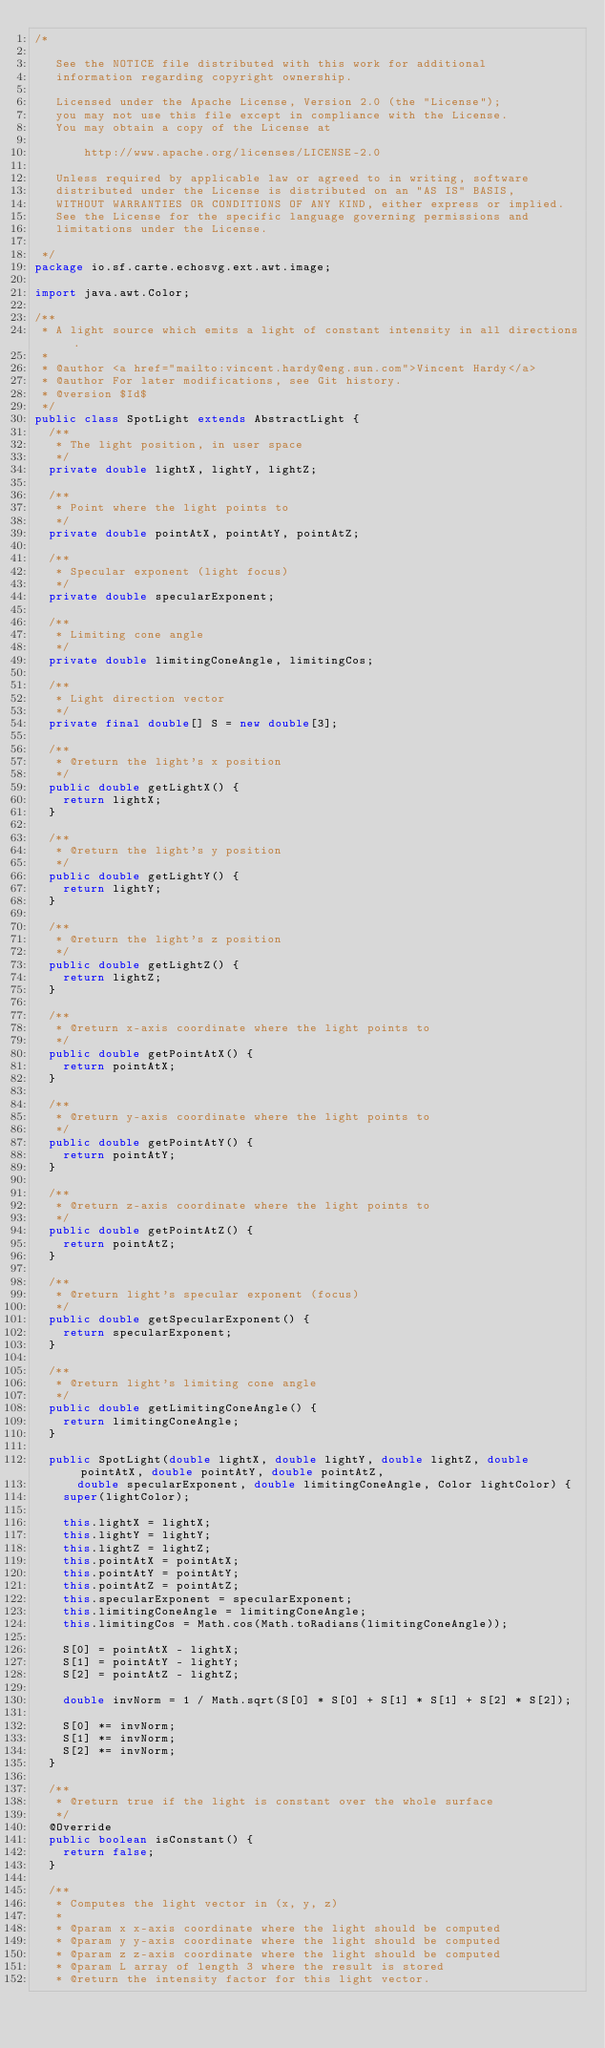Convert code to text. <code><loc_0><loc_0><loc_500><loc_500><_Java_>/*

   See the NOTICE file distributed with this work for additional
   information regarding copyright ownership.

   Licensed under the Apache License, Version 2.0 (the "License");
   you may not use this file except in compliance with the License.
   You may obtain a copy of the License at

       http://www.apache.org/licenses/LICENSE-2.0

   Unless required by applicable law or agreed to in writing, software
   distributed under the License is distributed on an "AS IS" BASIS,
   WITHOUT WARRANTIES OR CONDITIONS OF ANY KIND, either express or implied.
   See the License for the specific language governing permissions and
   limitations under the License.

 */
package io.sf.carte.echosvg.ext.awt.image;

import java.awt.Color;

/**
 * A light source which emits a light of constant intensity in all directions.
 *
 * @author <a href="mailto:vincent.hardy@eng.sun.com">Vincent Hardy</a>
 * @author For later modifications, see Git history.
 * @version $Id$
 */
public class SpotLight extends AbstractLight {
	/**
	 * The light position, in user space
	 */
	private double lightX, lightY, lightZ;

	/**
	 * Point where the light points to
	 */
	private double pointAtX, pointAtY, pointAtZ;

	/**
	 * Specular exponent (light focus)
	 */
	private double specularExponent;

	/**
	 * Limiting cone angle
	 */
	private double limitingConeAngle, limitingCos;

	/**
	 * Light direction vector
	 */
	private final double[] S = new double[3];

	/**
	 * @return the light's x position
	 */
	public double getLightX() {
		return lightX;
	}

	/**
	 * @return the light's y position
	 */
	public double getLightY() {
		return lightY;
	}

	/**
	 * @return the light's z position
	 */
	public double getLightZ() {
		return lightZ;
	}

	/**
	 * @return x-axis coordinate where the light points to
	 */
	public double getPointAtX() {
		return pointAtX;
	}

	/**
	 * @return y-axis coordinate where the light points to
	 */
	public double getPointAtY() {
		return pointAtY;
	}

	/**
	 * @return z-axis coordinate where the light points to
	 */
	public double getPointAtZ() {
		return pointAtZ;
	}

	/**
	 * @return light's specular exponent (focus)
	 */
	public double getSpecularExponent() {
		return specularExponent;
	}

	/**
	 * @return light's limiting cone angle
	 */
	public double getLimitingConeAngle() {
		return limitingConeAngle;
	}

	public SpotLight(double lightX, double lightY, double lightZ, double pointAtX, double pointAtY, double pointAtZ,
			double specularExponent, double limitingConeAngle, Color lightColor) {
		super(lightColor);

		this.lightX = lightX;
		this.lightY = lightY;
		this.lightZ = lightZ;
		this.pointAtX = pointAtX;
		this.pointAtY = pointAtY;
		this.pointAtZ = pointAtZ;
		this.specularExponent = specularExponent;
		this.limitingConeAngle = limitingConeAngle;
		this.limitingCos = Math.cos(Math.toRadians(limitingConeAngle));

		S[0] = pointAtX - lightX;
		S[1] = pointAtY - lightY;
		S[2] = pointAtZ - lightZ;

		double invNorm = 1 / Math.sqrt(S[0] * S[0] + S[1] * S[1] + S[2] * S[2]);

		S[0] *= invNorm;
		S[1] *= invNorm;
		S[2] *= invNorm;
	}

	/**
	 * @return true if the light is constant over the whole surface
	 */
	@Override
	public boolean isConstant() {
		return false;
	}

	/**
	 * Computes the light vector in (x, y, z)
	 *
	 * @param x x-axis coordinate where the light should be computed
	 * @param y y-axis coordinate where the light should be computed
	 * @param z z-axis coordinate where the light should be computed
	 * @param L array of length 3 where the result is stored
	 * @return the intensity factor for this light vector.</code> 